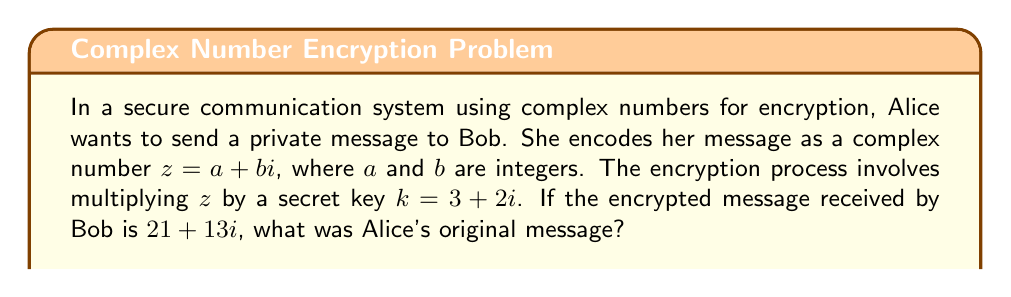Teach me how to tackle this problem. Let's approach this step-by-step:

1) The encryption process is represented by the multiplication of two complex numbers:
   $$(a + bi)(3 + 2i) = 21 + 13i$$

2) Expanding the left side of the equation:
   $$(3a - 2b) + (2a + 3b)i = 21 + 13i$$

3) Equating the real and imaginary parts:
   $$3a - 2b = 21$$
   $$2a + 3b = 13$$

4) We now have a system of two equations with two unknowns:
   $$\begin{cases}
   3a - 2b = 21 \\
   2a + 3b = 13
   \end{cases}$$

5) Multiply the second equation by 3 and the first equation by 2:
   $$\begin{cases}
   6a - 4b = 42 \\
   6a + 9b = 39
   \end{cases}$$

6) Subtracting the first equation from the second:
   $$13b = -3$$

7) Solving for $b$:
   $$b = -\frac{3}{13}$$

8) Since $a$ and $b$ are integers, we need to find a fraction that equals $-\frac{3}{13}$ and has an integer numerator and denominator. The simplest solution is:
   $$b = -3$$

9) Substituting this value back into one of our original equations:
   $$3a - 2(-3) = 21$$
   $$3a + 6 = 21$$
   $$3a = 15$$
   $$a = 5$$

Therefore, Alice's original message was $z = 5 - 3i$.
Answer: $5 - 3i$ 